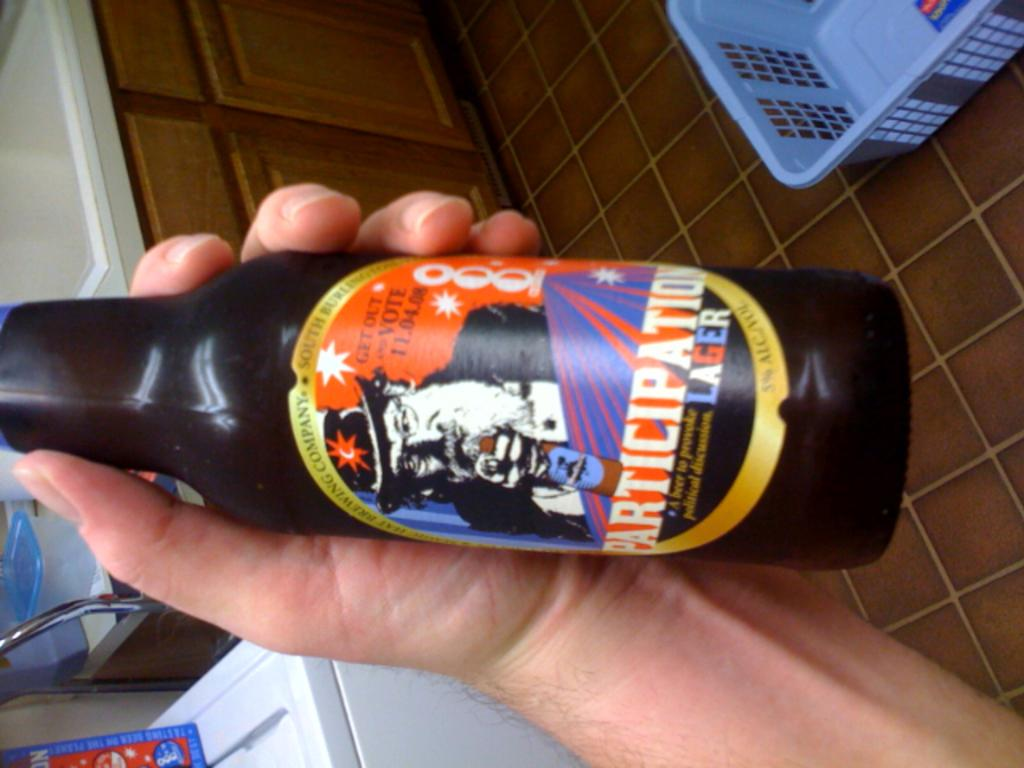<image>
Share a concise interpretation of the image provided. A person holding a bottle of lager with get out and vote on the sticker. 